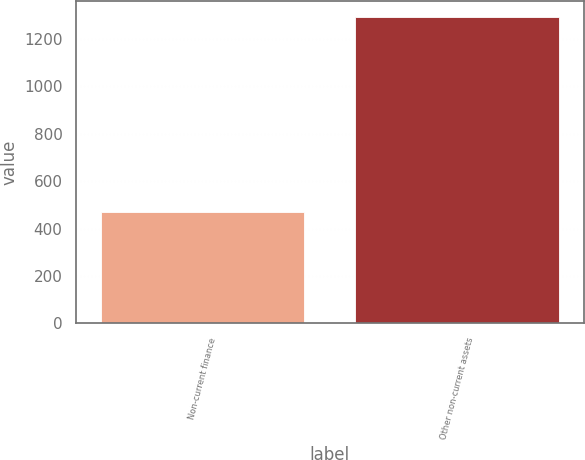<chart> <loc_0><loc_0><loc_500><loc_500><bar_chart><fcel>Non-current finance<fcel>Other non-current assets<nl><fcel>471<fcel>1294<nl></chart> 